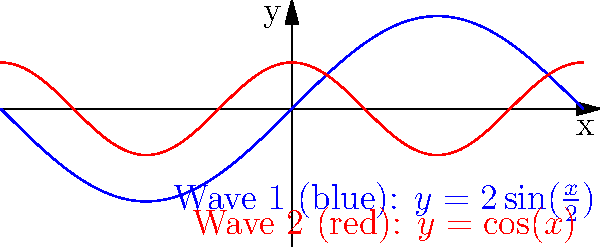A ship is navigating through an area where two wave patterns intersect, as shown in the graph. Wave 1 is represented by $y=2\sin(\frac{x}{2})$ (blue) and Wave 2 by $y=\cos(x)$ (red), where $x$ is in radians and $y$ is the wave height in meters. At what point(s) do the waves have the same slope, potentially causing maximum instability for the ship? Express your answer in terms of $\pi$. To find where the waves have the same slope, we need to follow these steps:

1) First, calculate the derivatives of both wave functions to get their slopes:
   For Wave 1: $\frac{d}{dx}(2\sin(\frac{x}{2})) = \cos(\frac{x}{2})$
   For Wave 2: $\frac{d}{dx}(\cos(x)) = -\sin(x)$

2) Set these derivatives equal to each other:
   $\cos(\frac{x}{2}) = -\sin(x)$

3) Use the double angle formula for sine: $\sin(2\theta) = 2\sin(\theta)\cos(\theta)$
   Let $\theta = \frac{x}{2}$, then:
   $\cos(\theta) = -\sin(2\theta) = -2\sin(\theta)\cos(\theta)$

4) Divide both sides by $\cos(\theta)$ (assuming $\cos(\theta) \neq 0$):
   $1 = -2\sin(\theta)$

5) Solve for $\theta$:
   $\sin(\theta) = -\frac{1}{2}$
   $\theta = \arcsin(-\frac{1}{2}) + 2\pi n$ or $\theta = \pi - \arcsin(-\frac{1}{2}) + 2\pi n$, where $n$ is an integer

6) Remember that $\theta = \frac{x}{2}$, so multiply by 2:
   $x = 2\arcsin(-\frac{1}{2}) + 4\pi n$ or $x = 2\pi - 2\arcsin(-\frac{1}{2}) + 4\pi n$

7) $\arcsin(-\frac{1}{2}) = -\frac{\pi}{6}$, so:
   $x = -\frac{\pi}{3} + 4\pi n$ or $x = \frac{7\pi}{3} + 4\pi n$

The waves have the same slope at these points, potentially causing maximum instability for the ship.
Answer: $x = -\frac{\pi}{3} + 4\pi n$ or $x = \frac{7\pi}{3} + 4\pi n$, where $n$ is an integer 